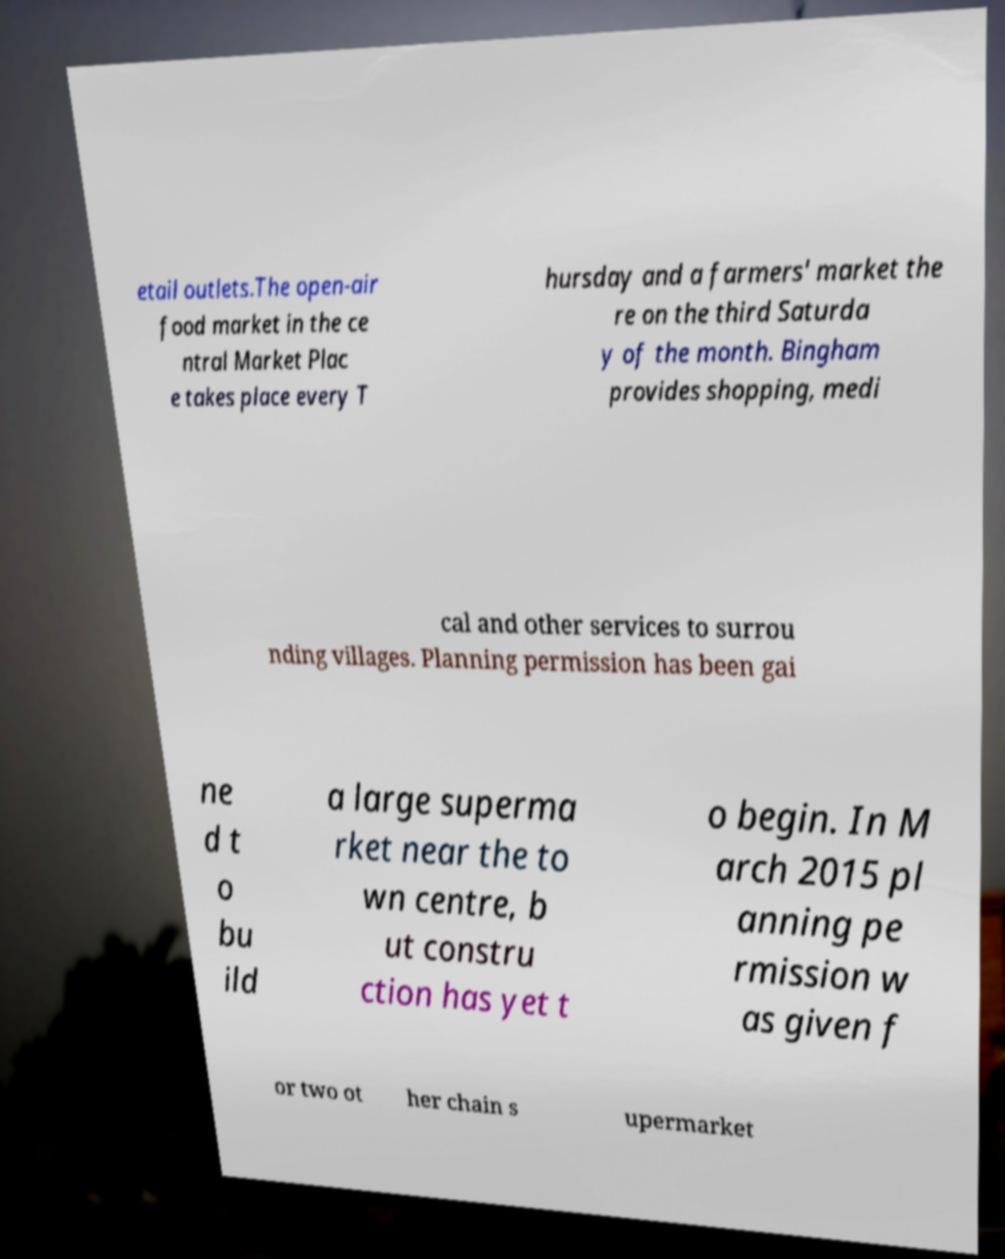For documentation purposes, I need the text within this image transcribed. Could you provide that? etail outlets.The open-air food market in the ce ntral Market Plac e takes place every T hursday and a farmers' market the re on the third Saturda y of the month. Bingham provides shopping, medi cal and other services to surrou nding villages. Planning permission has been gai ne d t o bu ild a large superma rket near the to wn centre, b ut constru ction has yet t o begin. In M arch 2015 pl anning pe rmission w as given f or two ot her chain s upermarket 